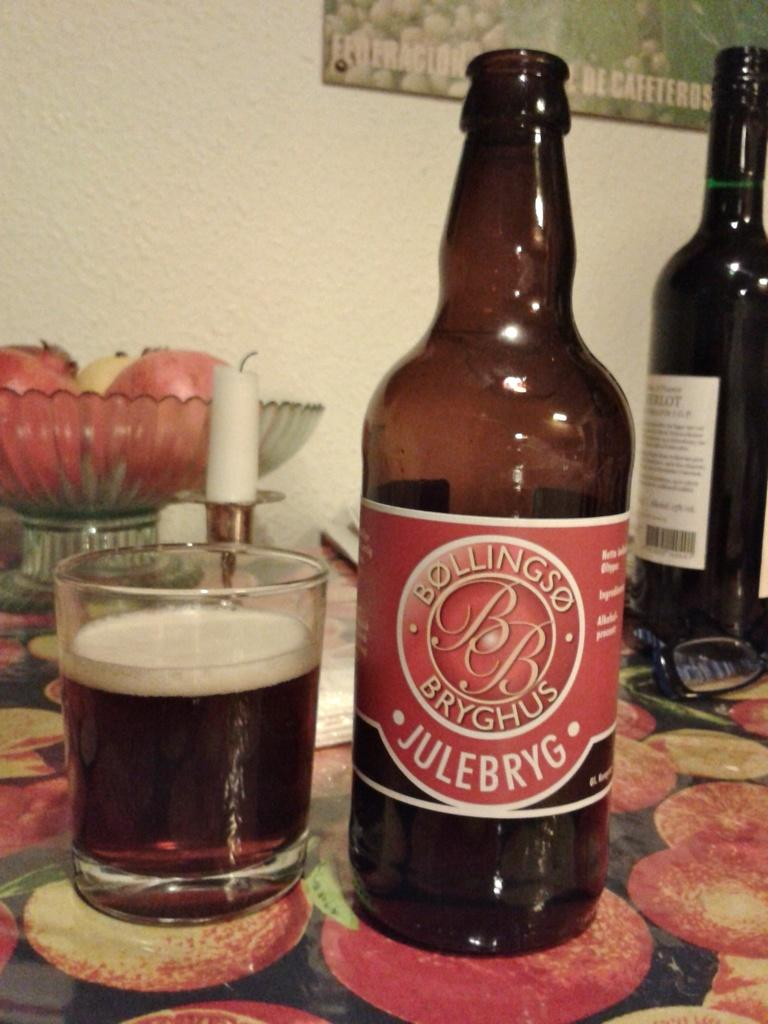<image>
Describe the image concisely. a bottle of bollingso bb bryghus julebryg next to a glass of it 